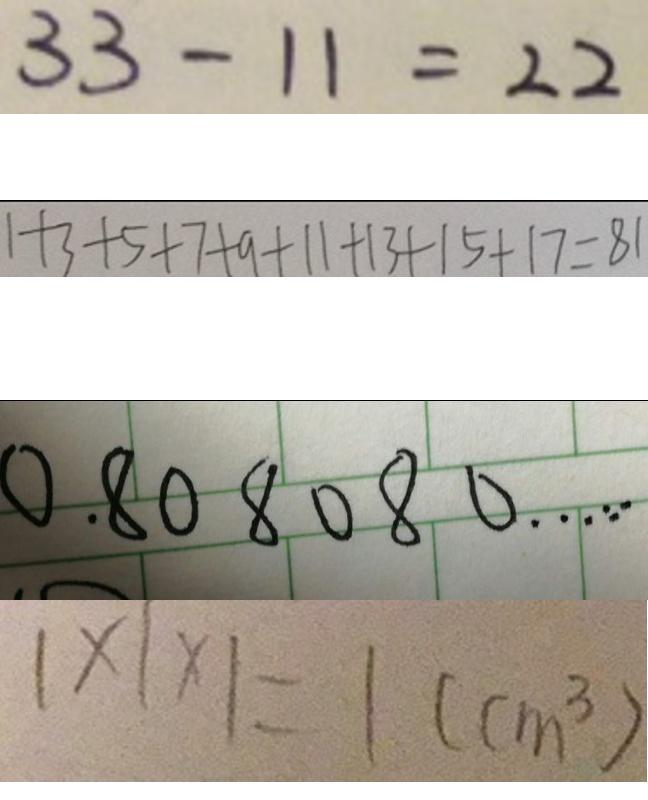<formula> <loc_0><loc_0><loc_500><loc_500>3 3 - 1 1 = 2 2 
 1 + 3 + 5 + 7 + 9 + 1 1 + 1 3 + 1 5 + 1 7 = 8 1 
 0 . 8 0 8 0 8 0 \cdots 
 1 \times 1 \times 1 = 1 ( c m ^ { 3 } )</formula> 